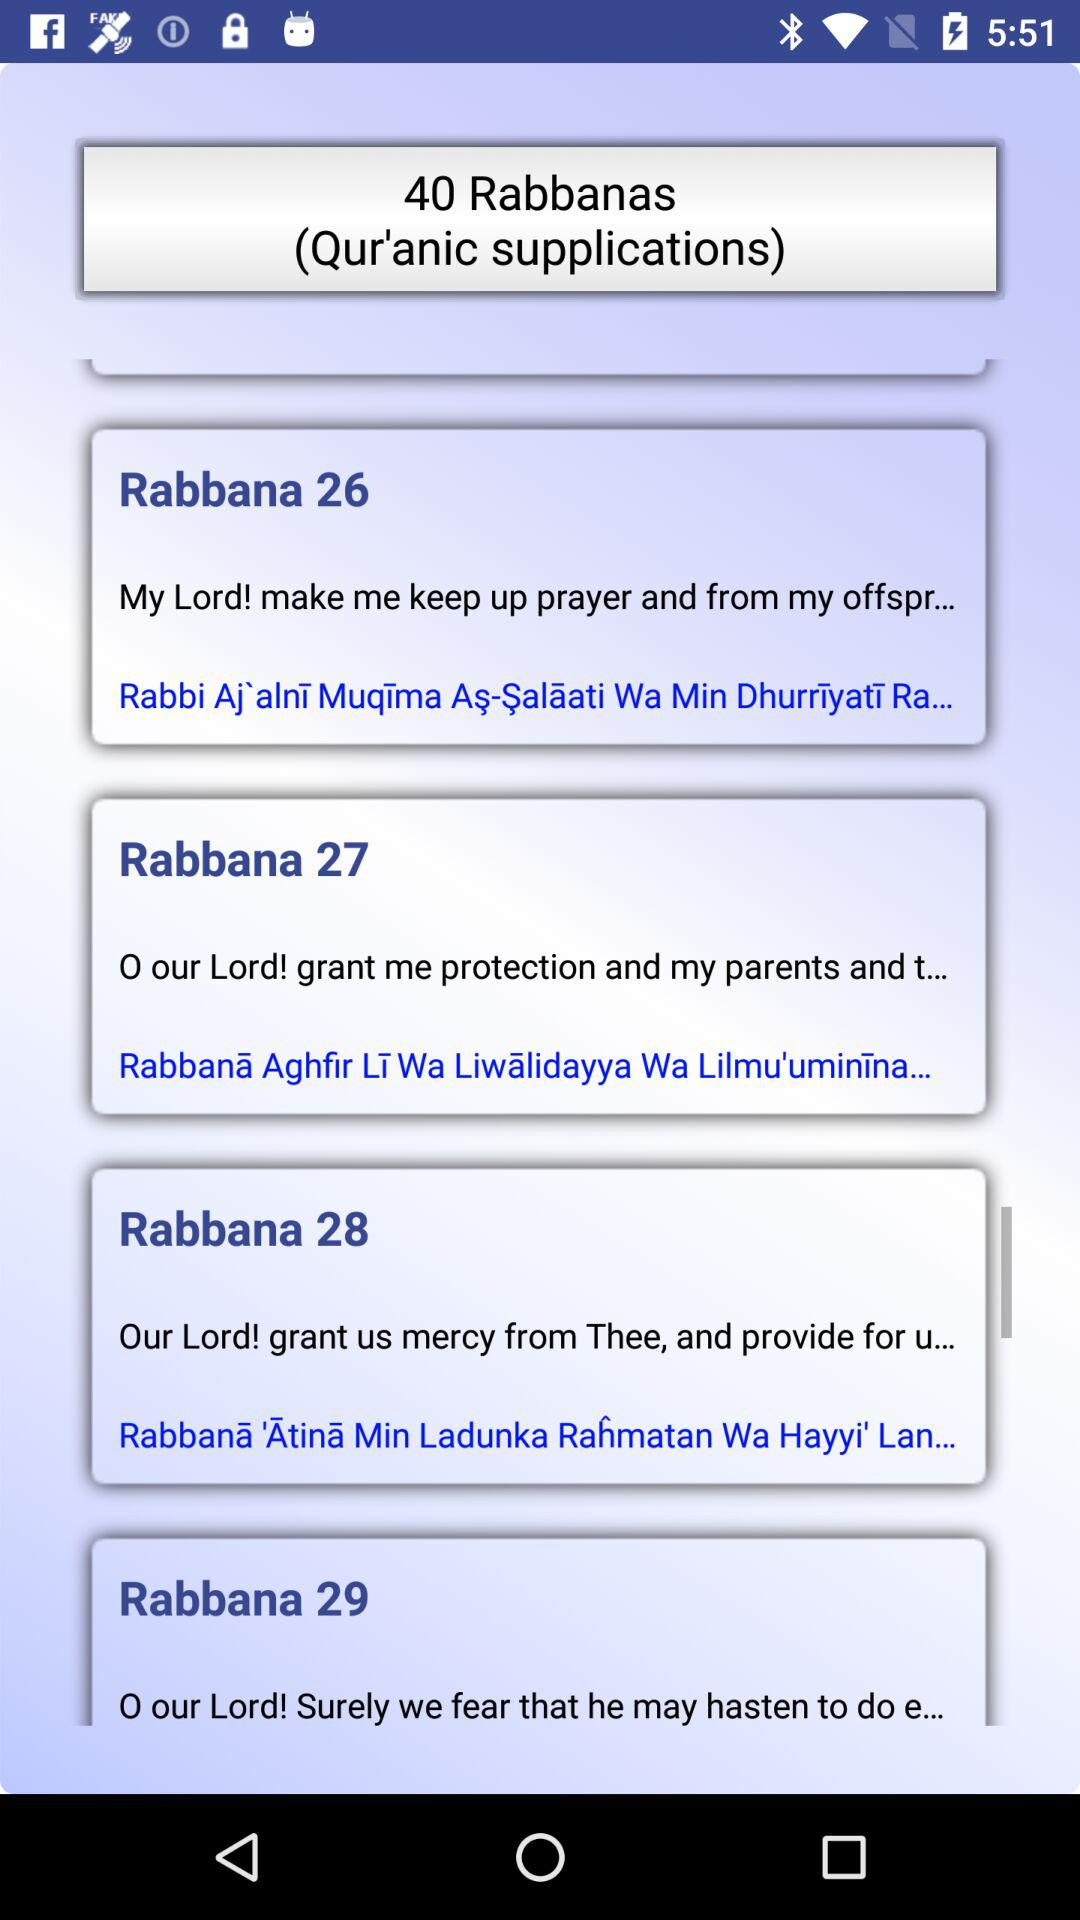How many pages is Rabbana 26?
When the provided information is insufficient, respond with <no answer>. <no answer> 